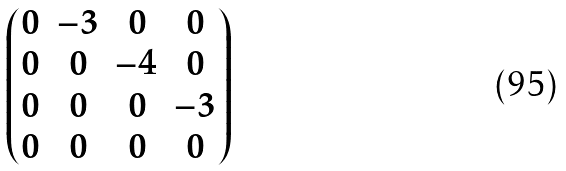Convert formula to latex. <formula><loc_0><loc_0><loc_500><loc_500>\begin{pmatrix} 0 & - 3 & 0 & 0 \\ 0 & 0 & - 4 & 0 \\ 0 & 0 & 0 & - 3 \\ 0 & 0 & 0 & 0 \end{pmatrix}</formula> 